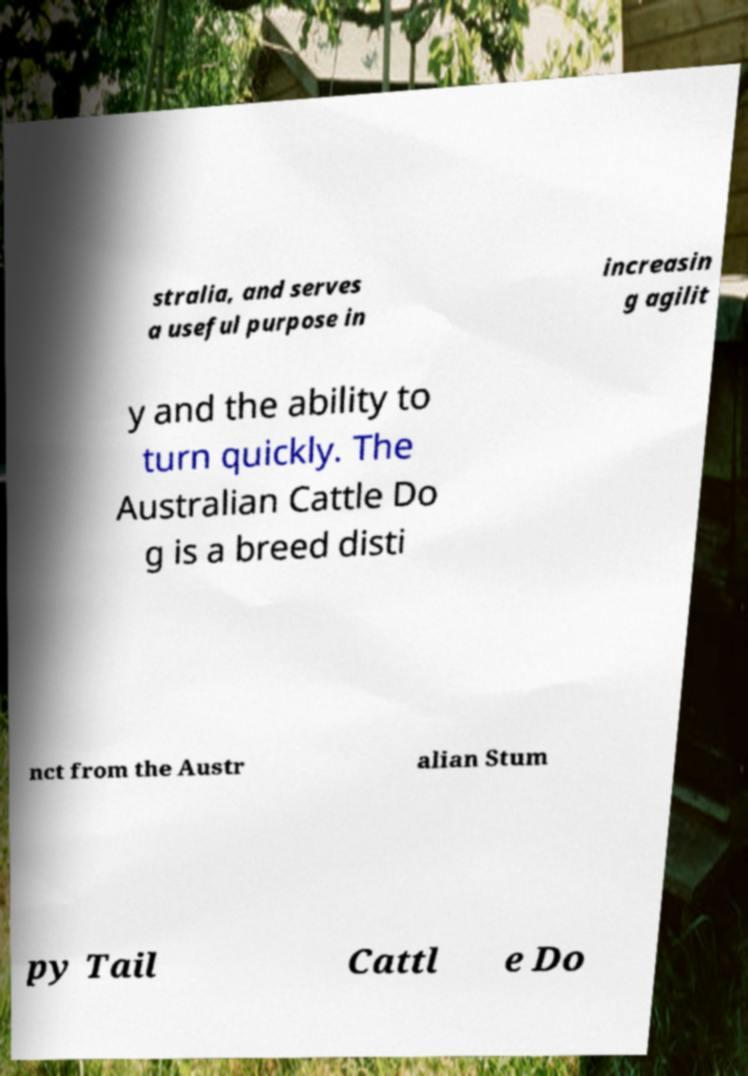Please read and relay the text visible in this image. What does it say? stralia, and serves a useful purpose in increasin g agilit y and the ability to turn quickly. The Australian Cattle Do g is a breed disti nct from the Austr alian Stum py Tail Cattl e Do 